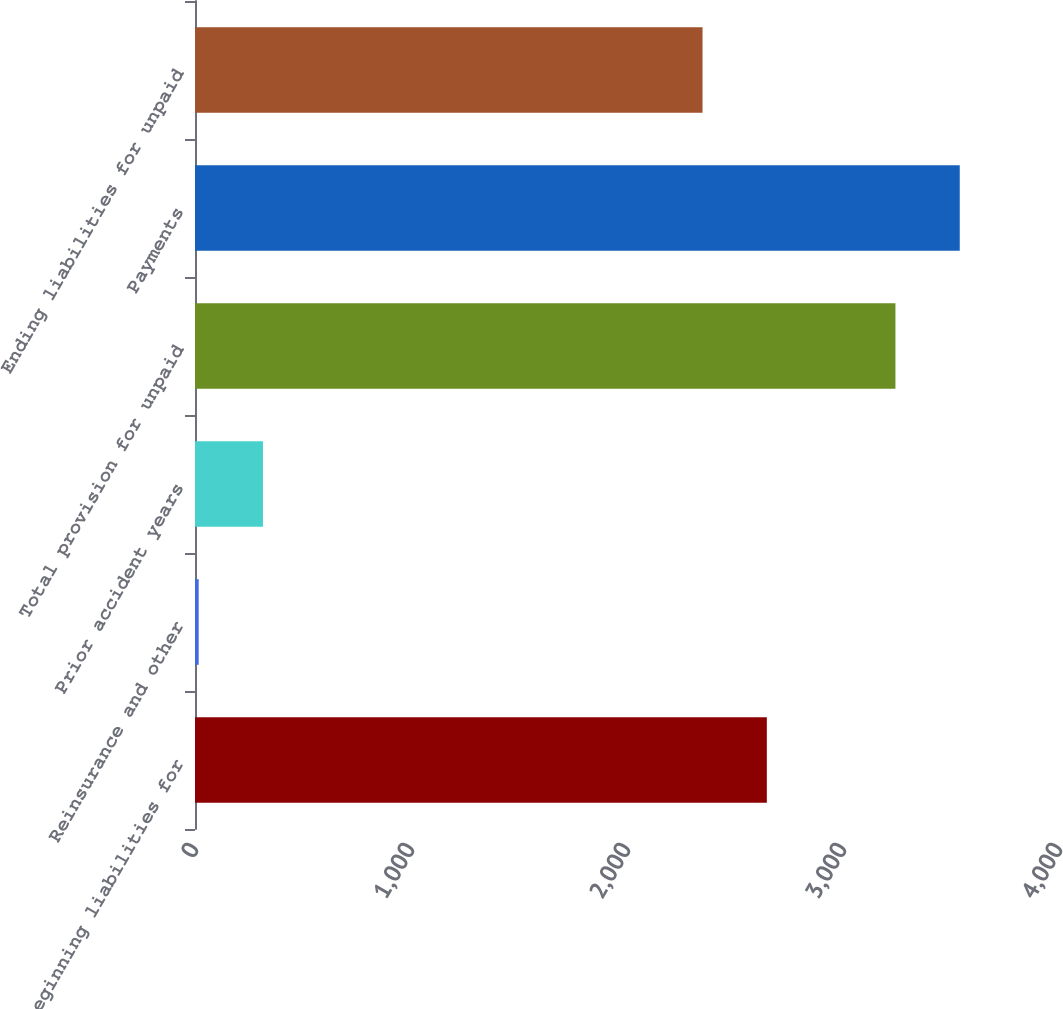Convert chart to OTSL. <chart><loc_0><loc_0><loc_500><loc_500><bar_chart><fcel>Beginning liabilities for<fcel>Reinsurance and other<fcel>Prior accident years<fcel>Total provision for unpaid<fcel>Payments<fcel>Ending liabilities for unpaid<nl><fcel>2647.4<fcel>17<fcel>314.7<fcel>3242.8<fcel>3540.5<fcel>2349.7<nl></chart> 